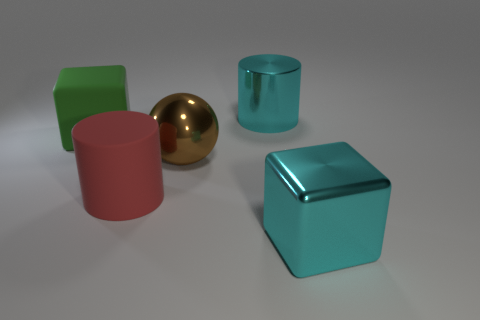Add 1 metal things. How many objects exist? 6 Subtract all cylinders. How many objects are left? 3 Add 5 matte things. How many matte things are left? 7 Add 2 big green objects. How many big green objects exist? 3 Subtract 0 gray cylinders. How many objects are left? 5 Subtract all tiny blue metallic cubes. Subtract all metallic objects. How many objects are left? 2 